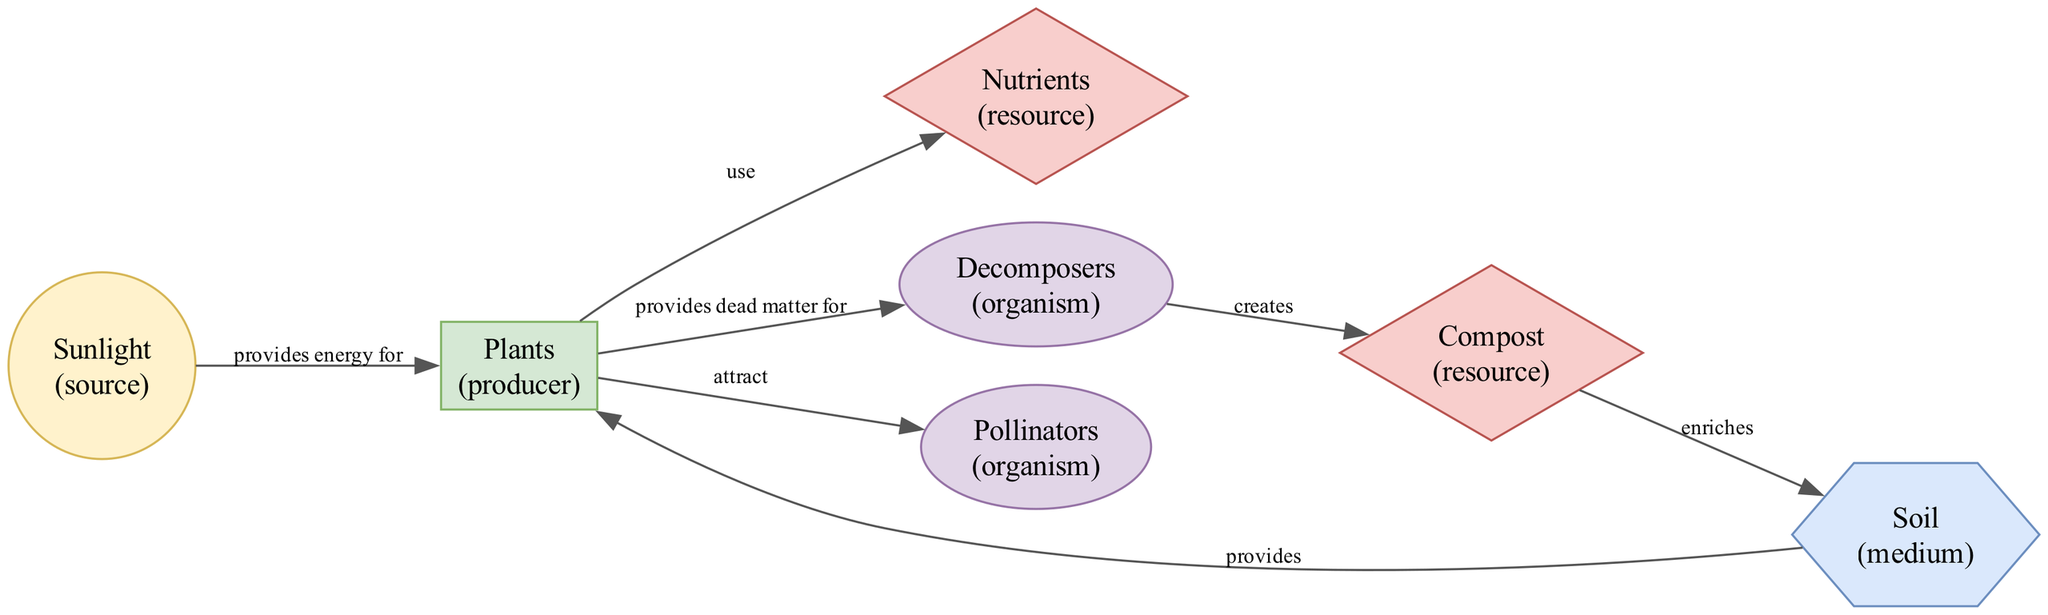What is the primary energy source for photosynthesis? The diagram indicates that "Sunlight" is the primary energy source for photosynthesis as it directly connects to "Plants" with the relationship effect of "provides energy for."
Answer: Sunlight How many nodes are in the diagram? By counting each unique element listed in the diagram, we find there are 7 nodes: Sunlight, Plants, Soil, Nutrients, Decomposers, Compost, and Pollinators.
Answer: 7 Which organism helps plants reproduce? The diagram shows "Pollinators" linked to "Plants," indicating that pollinators are the organisms that assist in plant reproduction by spreading pollen.
Answer: Pollinators What effect do "Decomposers" have on "Compost"? Based on the relationship described in the diagram, "Decomposers" create "Compost." This is reflected by the directed edge between the two nodes labeled with the effect "creates."
Answer: creates Which node enriches the soil? The diagram indicates that "Compost" enriches "Soil," as there is a directed edge from "Compost" to "Soil" with the relationship effect of "enriches."
Answer: Compost What are the essential minerals that "Plants" use? The diagram specifies that "Plants" use "Nutrients," indicating that nutrients are the essential minerals required for plant growth.
Answer: Nutrients Which nodes are linked through a direct resource flow? Analyzing the diagram, the nodes "Compost" and "Soil" have a direct resource flow evidenced by the edge labeled "enriches." Similarly, "Plants" and "Nutrients" are directly linked with the effect "use."
Answer: Compost to Soil, Plants to Nutrients How many edges are present in the diagram? Counting the connections between nodes shows there are 7 edges, each representing a relationship among elements in the garden ecosystem.
Answer: 7 